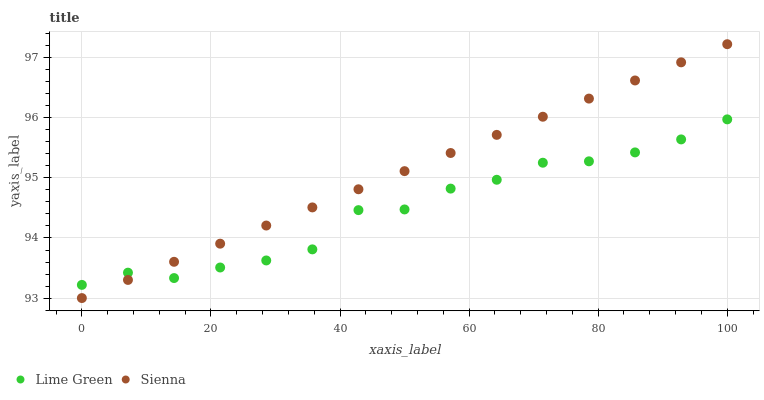Does Lime Green have the minimum area under the curve?
Answer yes or no. Yes. Does Sienna have the maximum area under the curve?
Answer yes or no. Yes. Does Lime Green have the maximum area under the curve?
Answer yes or no. No. Is Sienna the smoothest?
Answer yes or no. Yes. Is Lime Green the roughest?
Answer yes or no. Yes. Is Lime Green the smoothest?
Answer yes or no. No. Does Sienna have the lowest value?
Answer yes or no. Yes. Does Lime Green have the lowest value?
Answer yes or no. No. Does Sienna have the highest value?
Answer yes or no. Yes. Does Lime Green have the highest value?
Answer yes or no. No. Does Sienna intersect Lime Green?
Answer yes or no. Yes. Is Sienna less than Lime Green?
Answer yes or no. No. Is Sienna greater than Lime Green?
Answer yes or no. No. 